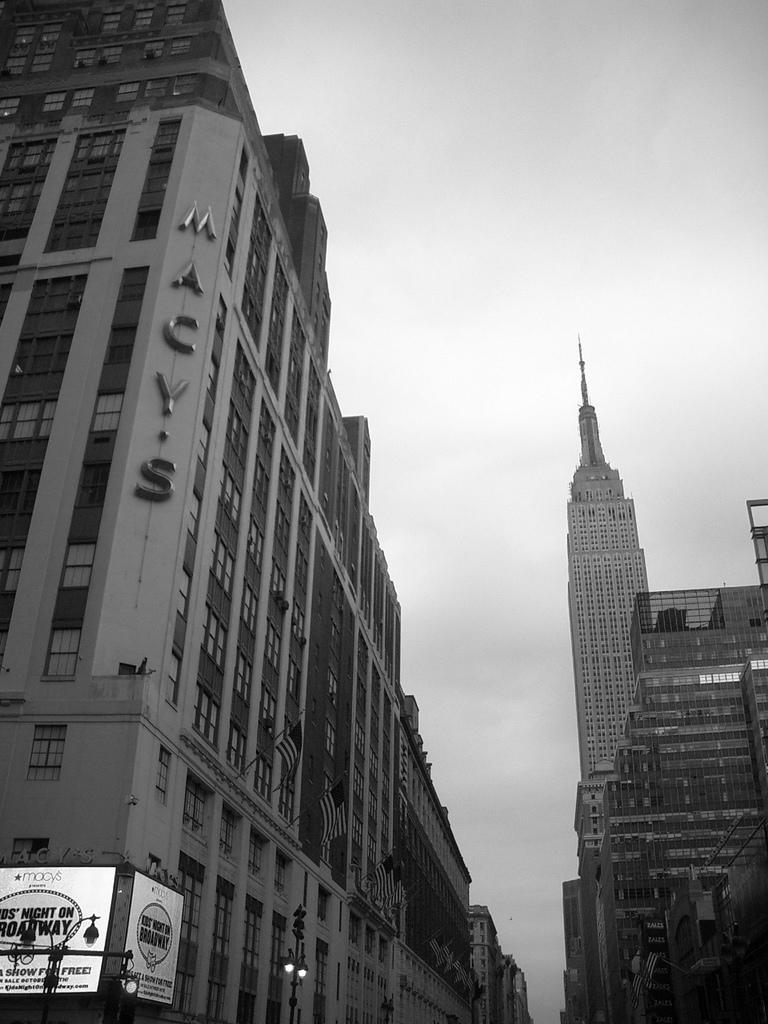What type of structures are visible in the image? There are huge buildings and towers in the image. Can you describe any specific features of these structures? The image shows a board with some names attached to a building on the left side. What type of clam can be seen holding a yoke in the image? There is no clam or yoke present in the image; it features huge buildings and towers with a board attached to one of them. 